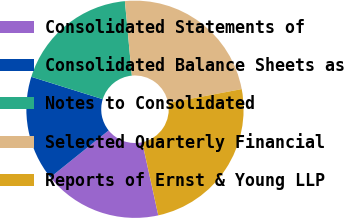<chart> <loc_0><loc_0><loc_500><loc_500><pie_chart><fcel>Consolidated Statements of<fcel>Consolidated Balance Sheets as<fcel>Notes to Consolidated<fcel>Selected Quarterly Financial<fcel>Reports of Ernst & Young LLP<nl><fcel>17.66%<fcel>15.61%<fcel>18.69%<fcel>23.51%<fcel>24.53%<nl></chart> 